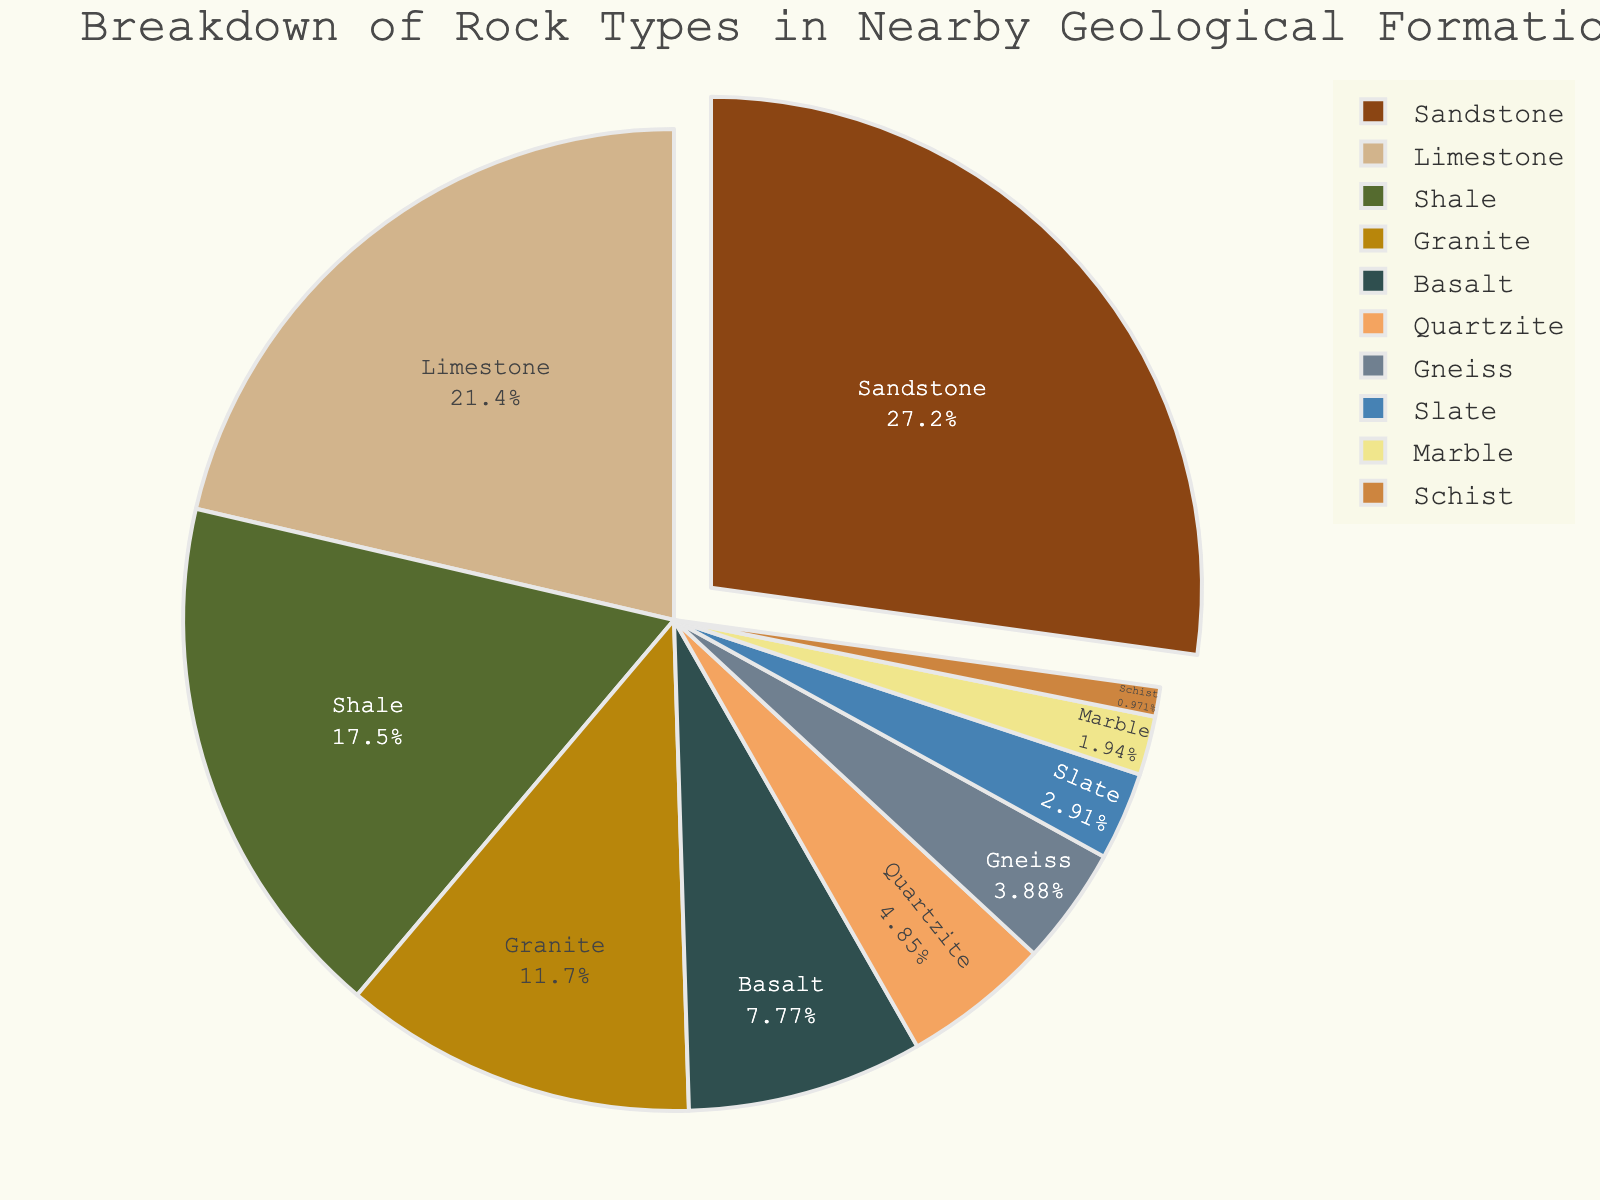What is the most common rock type in the geological formation? The chart shows which rock type has the largest percentage. Sandstone has the highest percentage at 28%.
Answer: Sandstone What is the combined percentage of Limestone and Shale? According to the pie chart, Limestone accounts for 22% and Shale accounts for 18%. Their combined percentage is 22% + 18% = 40%.
Answer: 40% Which rock type has the smallest percentage? The pie chart indicates the smallest segment. Schist has the smallest percentage at 1%.
Answer: Schist How many rock types make up at least 10% each of the geological formation? The pie chart shows percentages for each rock type. Sandstone (28%), Limestone (22%), Shale (18%), and Granite (12%) are all at least 10%. There are 4 rock types.
Answer: 4 Is the percentage of Basalt greater than that of Quartzite? Comparing the two sections, Basalt is 8% and Quartzite is 5%. Yes, 8% is greater than 5%.
Answer: Yes What is the percentage difference between Granite and Basalt? According to the chart, Granite is 12% and Basalt is 8%. The difference is 12% - 8% = 4%.
Answer: 4% What is the sum percentage of metamorphic rocks (Gneiss, Slate, Marble, Schist)? The pie chart gives the percentages: Gneiss (4%), Slate (3%), Marble (2%), and Schist (1%). Summing these, 4% + 3% + 2% + 1% = 10%.
Answer: 10% Which rock type is visually represented by a blue shade in the pie chart? The chart uses a custom color palette. Basalt is represented by a blue shade.
Answer: Basalt Is there more Shale or Quartzite? By how much? According to the pie chart, Shale is 18% and Quartzite is 5%. The difference is 18% - 5% = 13%.
Answer: Shale, 13% Compare the percentage of Granitic rocks (Granite and Gneiss) to Sandstone. Which is more, and by how much? Granite is 12% and Gneiss is 4%. Combined, they are 12% + 4% = 16%. Sandstone is 28%. Sandstone is more by 28% - 16% = 12%.
Answer: Sandstone, 12% 